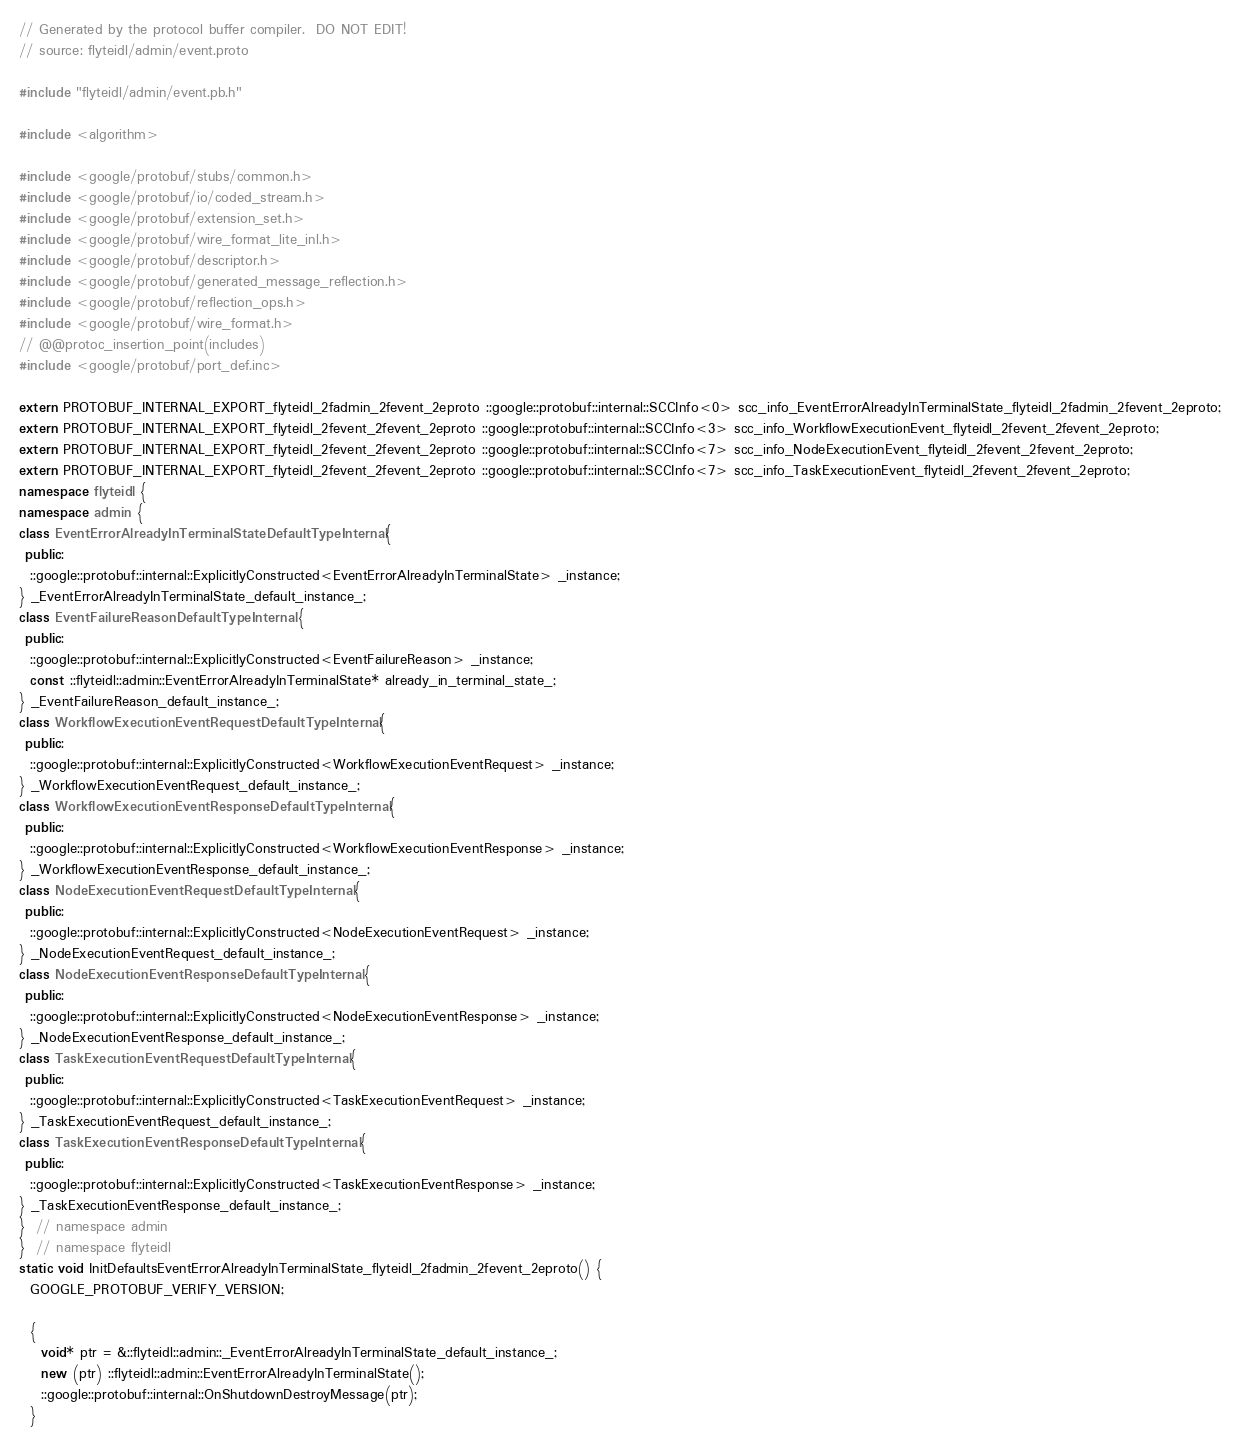<code> <loc_0><loc_0><loc_500><loc_500><_C++_>// Generated by the protocol buffer compiler.  DO NOT EDIT!
// source: flyteidl/admin/event.proto

#include "flyteidl/admin/event.pb.h"

#include <algorithm>

#include <google/protobuf/stubs/common.h>
#include <google/protobuf/io/coded_stream.h>
#include <google/protobuf/extension_set.h>
#include <google/protobuf/wire_format_lite_inl.h>
#include <google/protobuf/descriptor.h>
#include <google/protobuf/generated_message_reflection.h>
#include <google/protobuf/reflection_ops.h>
#include <google/protobuf/wire_format.h>
// @@protoc_insertion_point(includes)
#include <google/protobuf/port_def.inc>

extern PROTOBUF_INTERNAL_EXPORT_flyteidl_2fadmin_2fevent_2eproto ::google::protobuf::internal::SCCInfo<0> scc_info_EventErrorAlreadyInTerminalState_flyteidl_2fadmin_2fevent_2eproto;
extern PROTOBUF_INTERNAL_EXPORT_flyteidl_2fevent_2fevent_2eproto ::google::protobuf::internal::SCCInfo<3> scc_info_WorkflowExecutionEvent_flyteidl_2fevent_2fevent_2eproto;
extern PROTOBUF_INTERNAL_EXPORT_flyteidl_2fevent_2fevent_2eproto ::google::protobuf::internal::SCCInfo<7> scc_info_NodeExecutionEvent_flyteidl_2fevent_2fevent_2eproto;
extern PROTOBUF_INTERNAL_EXPORT_flyteidl_2fevent_2fevent_2eproto ::google::protobuf::internal::SCCInfo<7> scc_info_TaskExecutionEvent_flyteidl_2fevent_2fevent_2eproto;
namespace flyteidl {
namespace admin {
class EventErrorAlreadyInTerminalStateDefaultTypeInternal {
 public:
  ::google::protobuf::internal::ExplicitlyConstructed<EventErrorAlreadyInTerminalState> _instance;
} _EventErrorAlreadyInTerminalState_default_instance_;
class EventFailureReasonDefaultTypeInternal {
 public:
  ::google::protobuf::internal::ExplicitlyConstructed<EventFailureReason> _instance;
  const ::flyteidl::admin::EventErrorAlreadyInTerminalState* already_in_terminal_state_;
} _EventFailureReason_default_instance_;
class WorkflowExecutionEventRequestDefaultTypeInternal {
 public:
  ::google::protobuf::internal::ExplicitlyConstructed<WorkflowExecutionEventRequest> _instance;
} _WorkflowExecutionEventRequest_default_instance_;
class WorkflowExecutionEventResponseDefaultTypeInternal {
 public:
  ::google::protobuf::internal::ExplicitlyConstructed<WorkflowExecutionEventResponse> _instance;
} _WorkflowExecutionEventResponse_default_instance_;
class NodeExecutionEventRequestDefaultTypeInternal {
 public:
  ::google::protobuf::internal::ExplicitlyConstructed<NodeExecutionEventRequest> _instance;
} _NodeExecutionEventRequest_default_instance_;
class NodeExecutionEventResponseDefaultTypeInternal {
 public:
  ::google::protobuf::internal::ExplicitlyConstructed<NodeExecutionEventResponse> _instance;
} _NodeExecutionEventResponse_default_instance_;
class TaskExecutionEventRequestDefaultTypeInternal {
 public:
  ::google::protobuf::internal::ExplicitlyConstructed<TaskExecutionEventRequest> _instance;
} _TaskExecutionEventRequest_default_instance_;
class TaskExecutionEventResponseDefaultTypeInternal {
 public:
  ::google::protobuf::internal::ExplicitlyConstructed<TaskExecutionEventResponse> _instance;
} _TaskExecutionEventResponse_default_instance_;
}  // namespace admin
}  // namespace flyteidl
static void InitDefaultsEventErrorAlreadyInTerminalState_flyteidl_2fadmin_2fevent_2eproto() {
  GOOGLE_PROTOBUF_VERIFY_VERSION;

  {
    void* ptr = &::flyteidl::admin::_EventErrorAlreadyInTerminalState_default_instance_;
    new (ptr) ::flyteidl::admin::EventErrorAlreadyInTerminalState();
    ::google::protobuf::internal::OnShutdownDestroyMessage(ptr);
  }</code> 